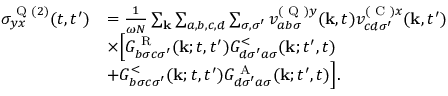Convert formula to latex. <formula><loc_0><loc_0><loc_500><loc_500>\begin{array} { r l } { \sigma _ { y x } ^ { Q ( 2 ) } ( t , t ^ { \prime } ) } & { = \frac { 1 } { \omega N } \sum _ { k } \sum _ { a , b , c , d } \sum _ { \sigma , \sigma ^ { \prime } } v _ { a b \sigma } ^ { ( Q ) y } ( k , t ) v _ { c d \sigma ^ { \prime } } ^ { ( C ) x } ( k , t ^ { \prime } ) } \\ & { \times \left [ G _ { b \sigma c \sigma ^ { \prime } } ^ { R } ( k ; t , t ^ { \prime } ) G _ { d \sigma ^ { \prime } a \sigma } ^ { < } ( k ; t ^ { \prime } , t ) } \\ & { + G _ { b \sigma c \sigma ^ { \prime } } ^ { < } ( k ; t , t ^ { \prime } ) G _ { d \sigma ^ { \prime } a \sigma } ^ { A } ( k ; t ^ { \prime } , t ) \right ] . } \end{array}</formula> 